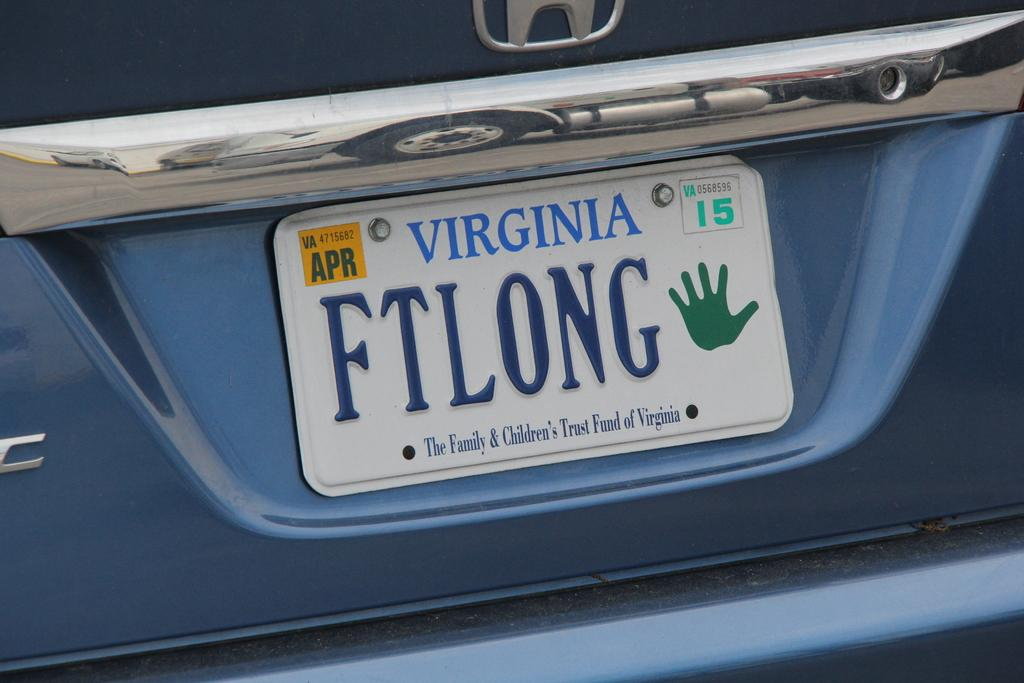<image>
Create a compact narrative representing the image presented. White Virginia license plate which says FTLONG on it. 